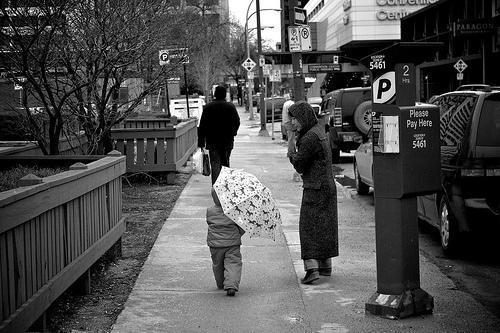How many bags is the guy carrying?
Give a very brief answer. 2. 